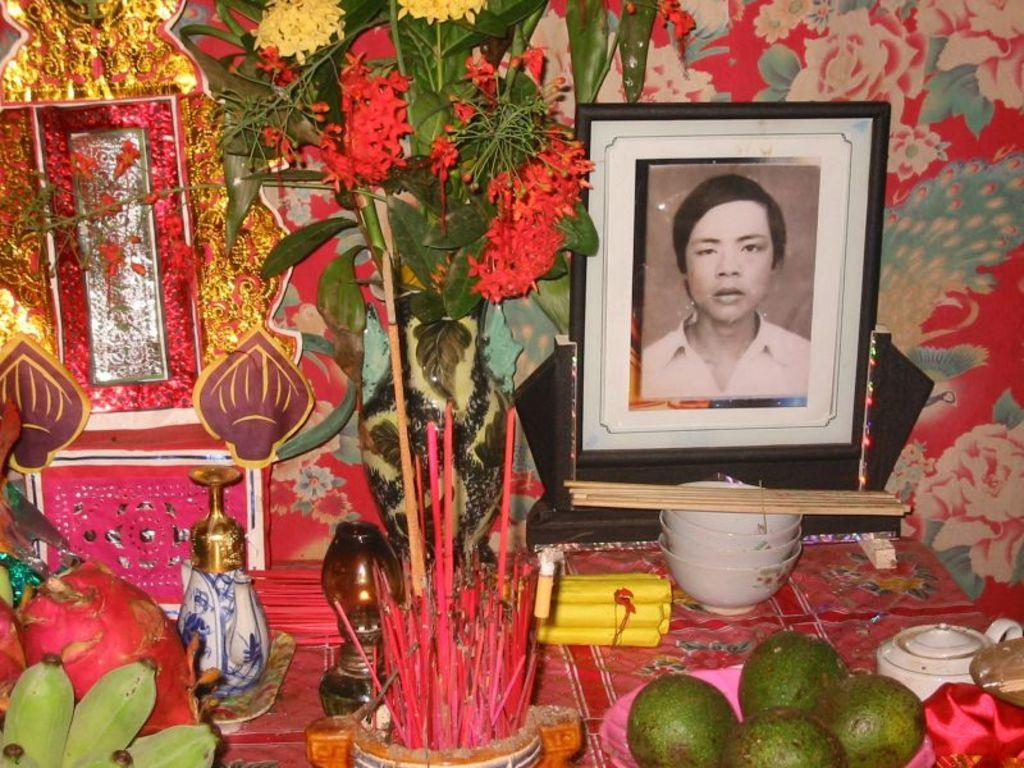What is located on the right side of the image? There is a frame on the right side of the image. What objects are in front of the frame? There are bowls, fruits, and flowers in front of the frame. Can you describe the other unspecified things in front of the frame? Unfortunately, the facts provided do not specify what these other unspecified things are. What type of clam is visible on the edge of the frame in the image? There is no clam visible on the edge of the frame in the image. 